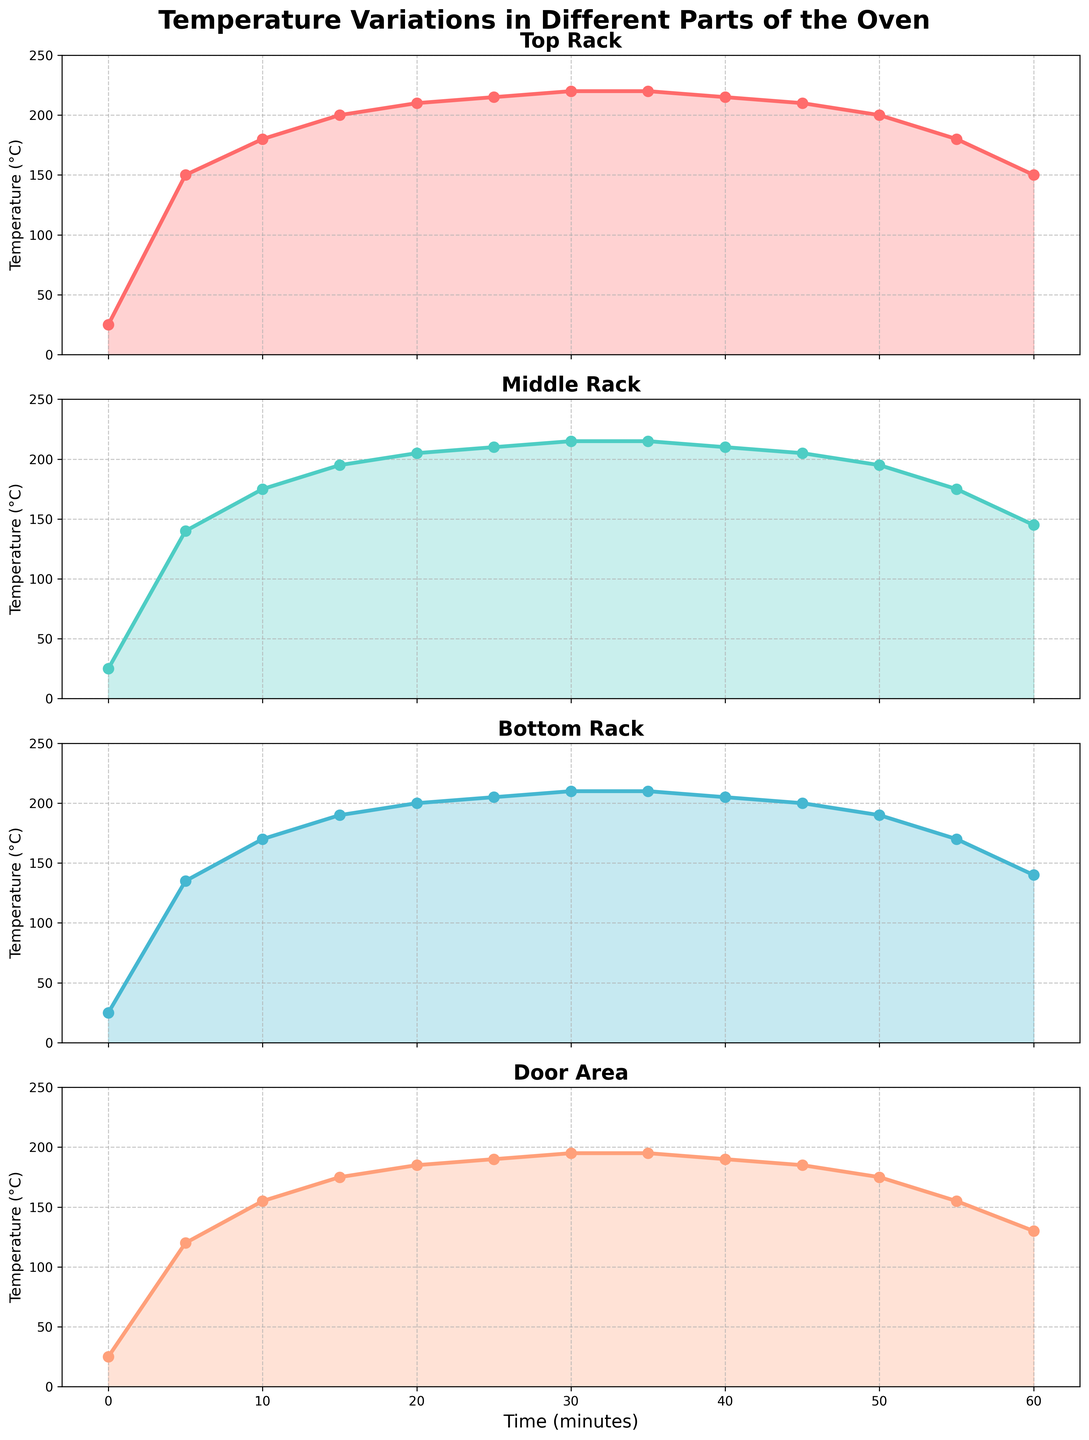When does the temperature on the Top Rack peak? The plot for the Top Rack shows that the temperature peaks around 30 minutes where it reaches the highest value before falling again.
Answer: 30 minutes Which part of the oven maintains the highest temperature overall? By examining all subplots, the Top Rack consistently reaches the highest temperature compared to the other parts.
Answer: Top Rack How does the temperature at the Door Area change as time progresses from 0 to 60 minutes? The temperature at the Door Area follows a pattern where it increases for the first 30 minutes, reaching about 195°C, and then decreases back to 130°C by the 60th minute.
Answer: Increases then decreases What is the temperature difference between the Middle Rack and the Bottom Rack at 20 minutes? At 20 minutes, the Middle Rack is at 205°C and the Bottom Rack is at 200°C. The difference is calculated as 205 - 200.
Answer: 5°C At what time does the Middle Rack reach a temperature of 210°C? By looking at the Middle Rack subplot, we see that the temperature reaches 210°C at around 25 minutes.
Answer: 25 minutes Which two racks have the closest temperatures at the 40-minute mark? At 40 minutes, the Top and Middle Racks both show temperatures close to 215°C and 210°C, respectively, with the least difference between them.
Answer: Top and Middle Racks Does any part of the oven maintain a steady temperature longer than others? The Bottom Rack temperatures maintain a steady value (210°C) from 30 to 35 minutes and again (205°C) from 35 to 40 minutes, which is similar to the Top Rack.
Answer: No, they are similar What is the overall trend of the temperatures in the Door Area from 0 to 60 minutes? The Door Area shows a steady increase from 25°C to a peak around 30 minutes at 195°C, followed by a decrease to 130°C by 60 minutes.
Answer: Increase then decrease Which part of the oven shows the most fluctuations in temperature? The Middle Rack experiences the most significant fluctuations with its peak temperature of 215°C at 30 minutes down to 145°C at 60 minutes.
Answer: Middle Rack Is there a time when all parts of the oven have approximately the same temperature? Around 50 to 55 minutes, all parts of the oven show a reducing trend with closely converging temperatures of approximately 190°C to 200°C.
Answer: Around 50 minutes 